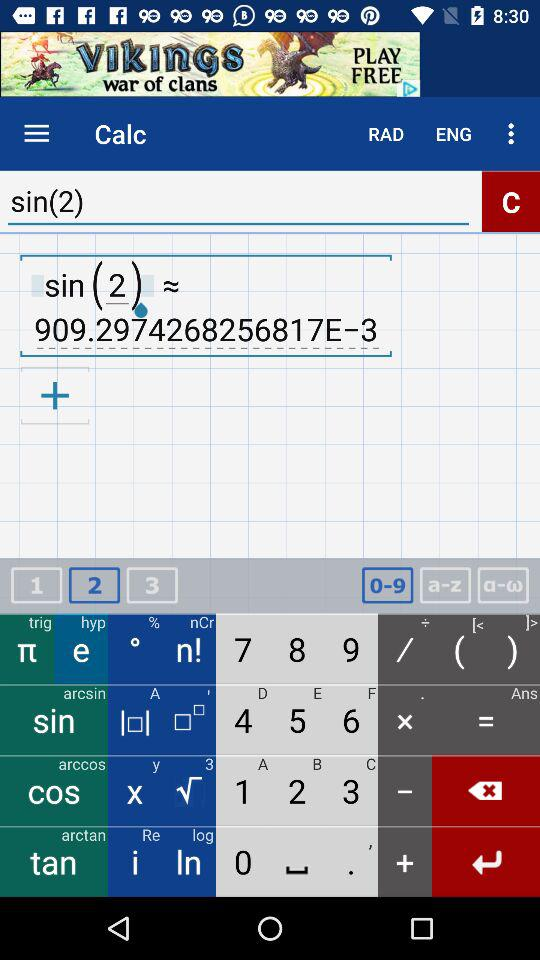What's the value of sin(2)? The value of sin(2) is 909.2974268256817E-3. 